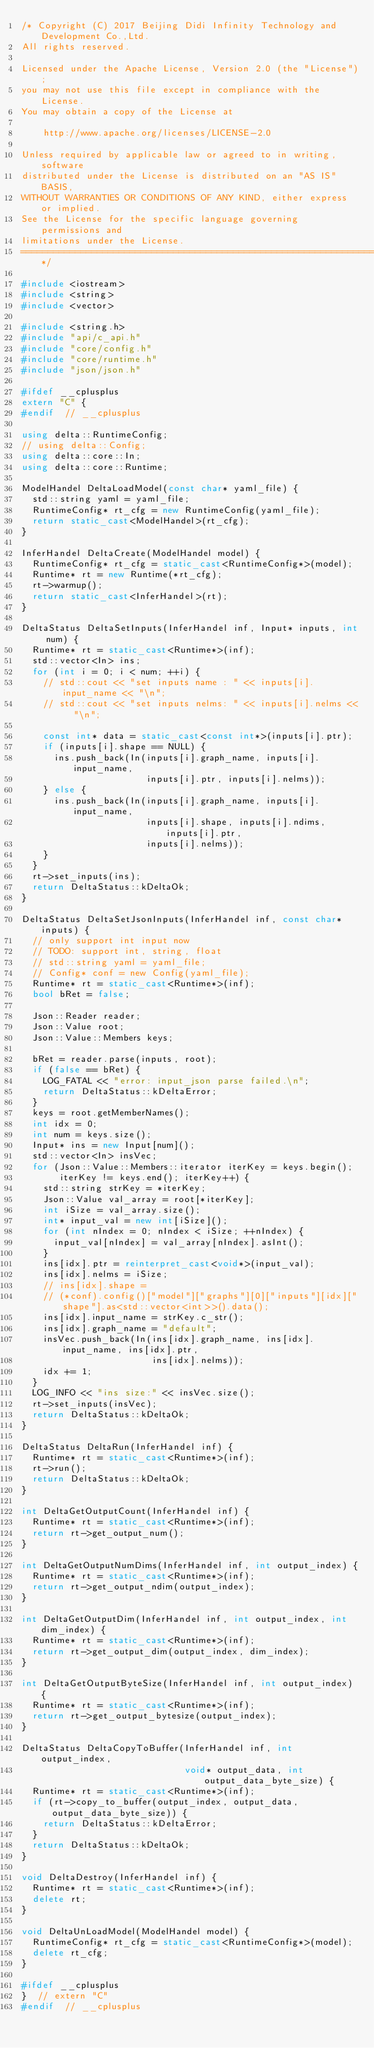<code> <loc_0><loc_0><loc_500><loc_500><_C++_>/* Copyright (C) 2017 Beijing Didi Infinity Technology and Development Co.,Ltd.
All rights reserved.

Licensed under the Apache License, Version 2.0 (the "License");
you may not use this file except in compliance with the License.
You may obtain a copy of the License at

    http://www.apache.org/licenses/LICENSE-2.0

Unless required by applicable law or agreed to in writing, software
distributed under the License is distributed on an "AS IS" BASIS,
WITHOUT WARRANTIES OR CONDITIONS OF ANY KIND, either express or implied.
See the License for the specific language governing permissions and
limitations under the License.
==============================================================================*/

#include <iostream>
#include <string>
#include <vector>

#include <string.h>
#include "api/c_api.h"
#include "core/config.h"
#include "core/runtime.h"
#include "json/json.h"

#ifdef __cplusplus
extern "C" {
#endif  // __cplusplus

using delta::RuntimeConfig;
// using delta::Config;
using delta::core::In;
using delta::core::Runtime;

ModelHandel DeltaLoadModel(const char* yaml_file) {
  std::string yaml = yaml_file;
  RuntimeConfig* rt_cfg = new RuntimeConfig(yaml_file);
  return static_cast<ModelHandel>(rt_cfg);
}

InferHandel DeltaCreate(ModelHandel model) {
  RuntimeConfig* rt_cfg = static_cast<RuntimeConfig*>(model);
  Runtime* rt = new Runtime(*rt_cfg);
  rt->warmup();
  return static_cast<InferHandel>(rt);
}

DeltaStatus DeltaSetInputs(InferHandel inf, Input* inputs, int num) {
  Runtime* rt = static_cast<Runtime*>(inf);
  std::vector<In> ins;
  for (int i = 0; i < num; ++i) {
    // std::cout << "set inputs name : " << inputs[i].input_name << "\n";
    // std::cout << "set inputs nelms: " << inputs[i].nelms <<  "\n";

    const int* data = static_cast<const int*>(inputs[i].ptr);
    if (inputs[i].shape == NULL) {
      ins.push_back(In(inputs[i].graph_name, inputs[i].input_name,
                       inputs[i].ptr, inputs[i].nelms));
    } else {
      ins.push_back(In(inputs[i].graph_name, inputs[i].input_name,
                       inputs[i].shape, inputs[i].ndims, inputs[i].ptr,
                       inputs[i].nelms));
    }
  }
  rt->set_inputs(ins);
  return DeltaStatus::kDeltaOk;
}

DeltaStatus DeltaSetJsonInputs(InferHandel inf, const char* inputs) {
  // only support int input now
  // TODO: support int, string, float
  // std::string yaml = yaml_file;
  // Config* conf = new Config(yaml_file);
  Runtime* rt = static_cast<Runtime*>(inf);
  bool bRet = false;

  Json::Reader reader;
  Json::Value root;
  Json::Value::Members keys;

  bRet = reader.parse(inputs, root);
  if (false == bRet) {
    LOG_FATAL << "error: input_json parse failed.\n";
    return DeltaStatus::kDeltaError;
  }
  keys = root.getMemberNames();
  int idx = 0;
  int num = keys.size();
  Input* ins = new Input[num]();
  std::vector<In> insVec;
  for (Json::Value::Members::iterator iterKey = keys.begin();
       iterKey != keys.end(); iterKey++) {
    std::string strKey = *iterKey;
    Json::Value val_array = root[*iterKey];
    int iSize = val_array.size();
    int* input_val = new int[iSize]();
    for (int nIndex = 0; nIndex < iSize; ++nIndex) {
      input_val[nIndex] = val_array[nIndex].asInt();
    }
    ins[idx].ptr = reinterpret_cast<void*>(input_val);
    ins[idx].nelms = iSize;
    // ins[idx].shape =
    // (*conf).config()["model"]["graphs"][0]["inputs"][idx]["shape"].as<std::vector<int>>().data();
    ins[idx].input_name = strKey.c_str();
    ins[idx].graph_name = "default";
    insVec.push_back(In(ins[idx].graph_name, ins[idx].input_name, ins[idx].ptr,
                        ins[idx].nelms));
    idx += 1;
  }
  LOG_INFO << "ins size:" << insVec.size();
  rt->set_inputs(insVec);
  return DeltaStatus::kDeltaOk;
}

DeltaStatus DeltaRun(InferHandel inf) {
  Runtime* rt = static_cast<Runtime*>(inf);
  rt->run();
  return DeltaStatus::kDeltaOk;
}

int DeltaGetOutputCount(InferHandel inf) {
  Runtime* rt = static_cast<Runtime*>(inf);
  return rt->get_output_num();
}

int DeltaGetOutputNumDims(InferHandel inf, int output_index) {
  Runtime* rt = static_cast<Runtime*>(inf);
  return rt->get_output_ndim(output_index);
}

int DeltaGetOutputDim(InferHandel inf, int output_index, int dim_index) {
  Runtime* rt = static_cast<Runtime*>(inf);
  return rt->get_output_dim(output_index, dim_index);
}

int DeltaGetOutputByteSize(InferHandel inf, int output_index) {
  Runtime* rt = static_cast<Runtime*>(inf);
  return rt->get_output_bytesize(output_index);
}

DeltaStatus DeltaCopyToBuffer(InferHandel inf, int output_index,
                              void* output_data, int output_data_byte_size) {
  Runtime* rt = static_cast<Runtime*>(inf);
  if (rt->copy_to_buffer(output_index, output_data, output_data_byte_size)) {
    return DeltaStatus::kDeltaError;
  }
  return DeltaStatus::kDeltaOk;
}

void DeltaDestroy(InferHandel inf) {
  Runtime* rt = static_cast<Runtime*>(inf);
  delete rt;
}

void DeltaUnLoadModel(ModelHandel model) {
  RuntimeConfig* rt_cfg = static_cast<RuntimeConfig*>(model);
  delete rt_cfg;
}

#ifdef __cplusplus
}  // extern "C"
#endif  // __cplusplus
</code> 